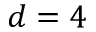<formula> <loc_0><loc_0><loc_500><loc_500>d = 4</formula> 